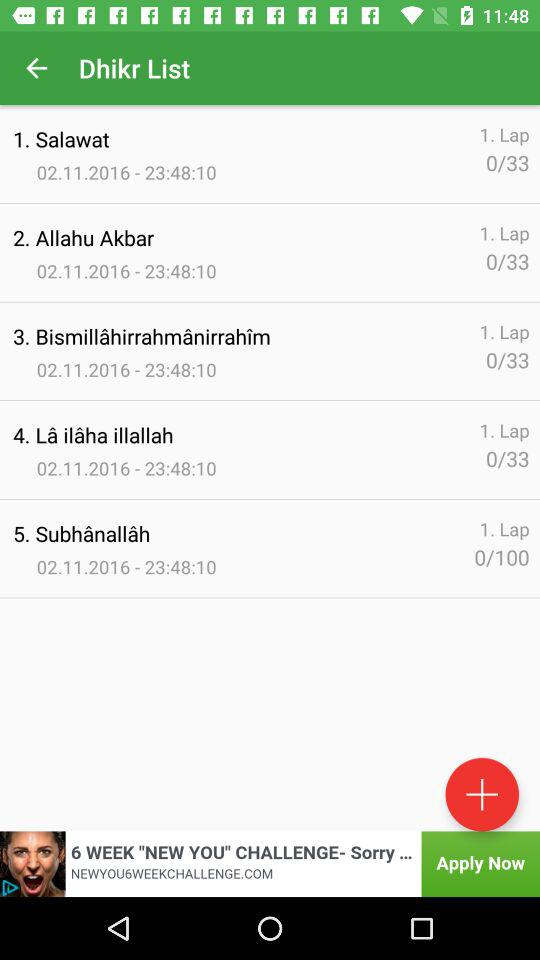What is the mentioned time for Salawat? The mentioned time is 23:48:10. 